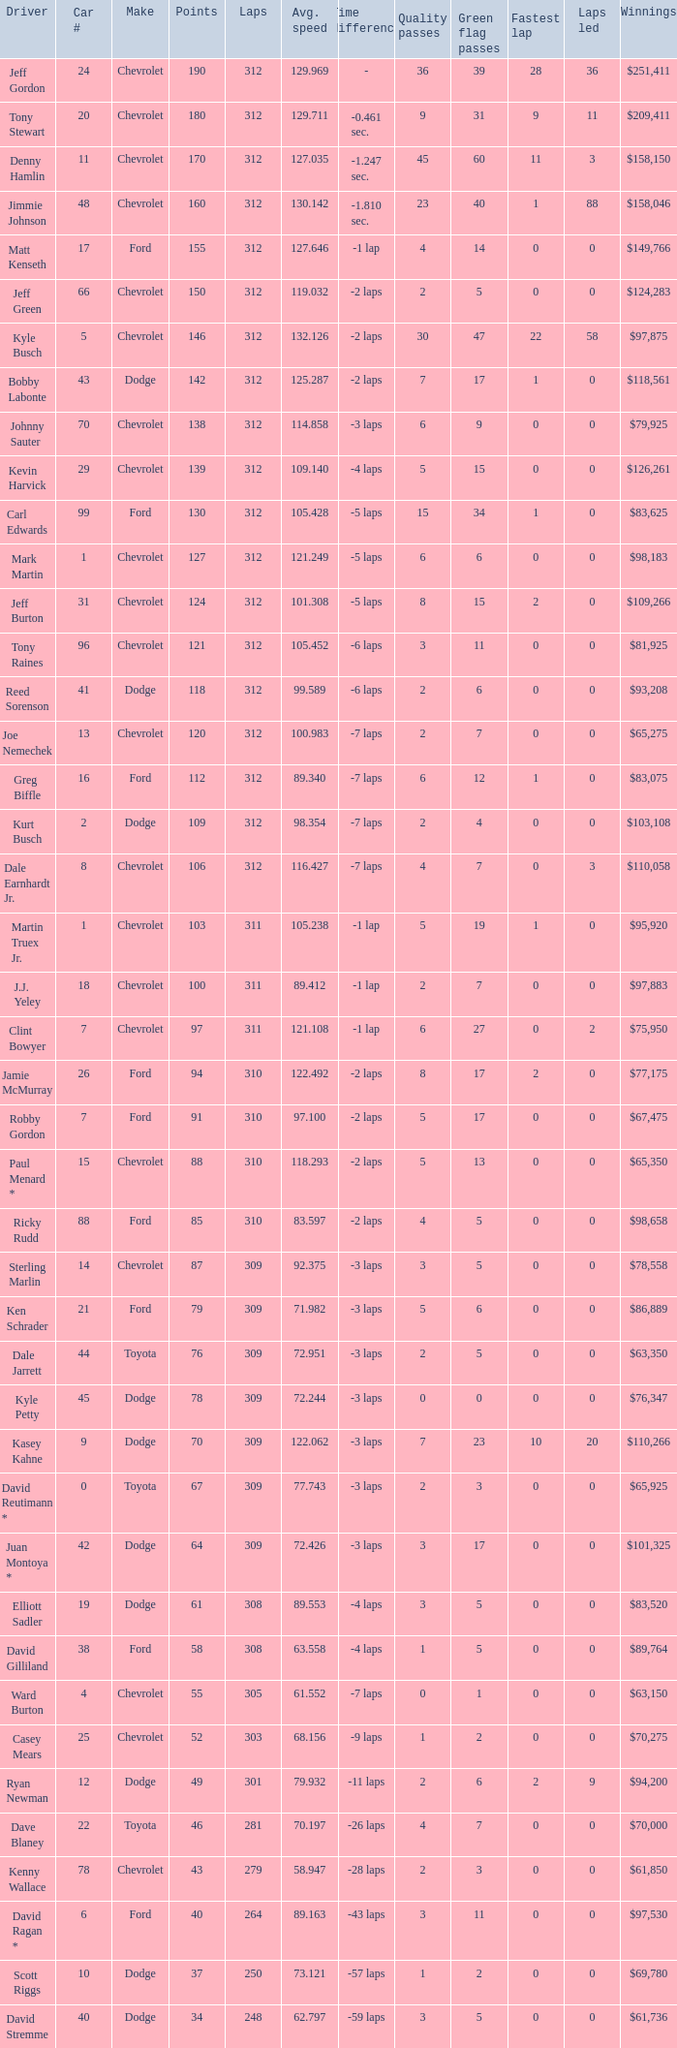What is the sum of laps that has a car number of larger than 1, is a ford, and has 155 points? 312.0. 